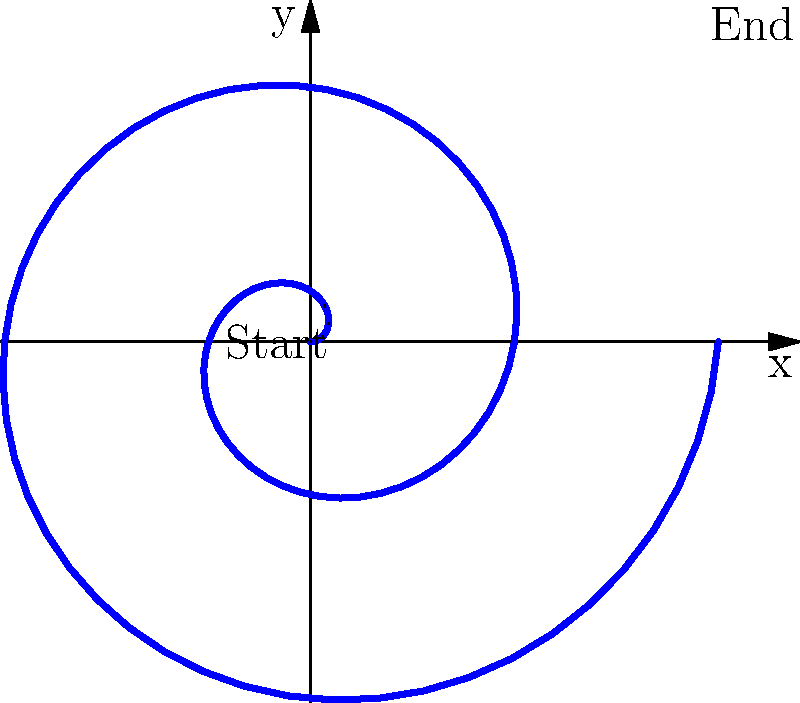In the context of circular storytelling techniques in comics, how does the spiral pattern shown in the polar coordinate system relate to narrative structure? Discuss the implications for both story progression and reader engagement. To analyze the relationship between the spiral pattern and narrative structure in comics, we can follow these steps:

1. Identify the structure: The graph shows a spiral in a polar coordinate system, starting from the center and moving outwards.

2. Relate to storytelling:
   a) The spiral represents a narrative that begins at a central point (origin) and expands outward.
   b) Each revolution of the spiral can be seen as a cycle or episode in the story.

3. Analyze progression:
   a) The continuous nature of the spiral indicates a fluid, unbroken narrative.
   b) As the spiral moves outward, it covers more area, suggesting story expansion or increasing complexity.

4. Interpret circular nature:
   a) The circular motion implies recurring themes, motifs, or plot elements.
   b) Each revolution builds upon the previous one, creating layers of meaning.

5. Consider reader engagement:
   a) The spiral draws the reader's eye inward and outward, mimicking the reading process in comics.
   b) This visual representation encourages readers to make connections between different parts of the narrative.

6. Examine pacing:
   a) The consistent growth of the spiral suggests a steady pace in storytelling.
   b) The expanding radius could represent intensifying drama or increasing stakes.

7. Relate to comic panel layout:
   a) The spiral could inspire circular or spiraling panel arrangements on a page.
   b) This layout would guide the reader's eye in a similar pattern, reinforcing the narrative structure.

8. Consider thematic implications:
   a) The spiral pattern might represent themes of growth, evolution, or the cyclical nature of events.
   b) It could also symbolize the interconnectedness of plot elements in a complex narrative.

This analysis demonstrates how a polar coordinate-based visualization can provide insights into the structure, pacing, and thematic elements of circular storytelling techniques in comics.
Answer: The spiral represents a narrative that expands and builds upon itself, with each revolution symbolizing story cycles, recurring themes, and increasing complexity, while guiding reader engagement through a visually dynamic structure. 